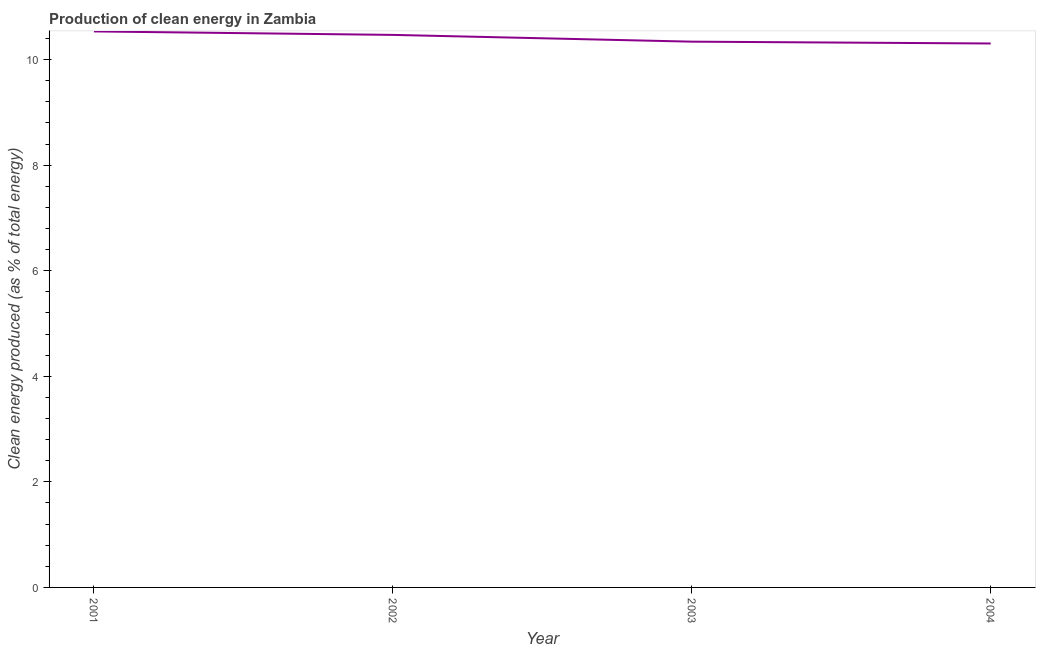What is the production of clean energy in 2001?
Your response must be concise. 10.53. Across all years, what is the maximum production of clean energy?
Offer a terse response. 10.53. Across all years, what is the minimum production of clean energy?
Your response must be concise. 10.3. In which year was the production of clean energy maximum?
Offer a terse response. 2001. What is the sum of the production of clean energy?
Ensure brevity in your answer.  41.64. What is the difference between the production of clean energy in 2002 and 2003?
Offer a terse response. 0.13. What is the average production of clean energy per year?
Offer a terse response. 10.41. What is the median production of clean energy?
Keep it short and to the point. 10.4. What is the ratio of the production of clean energy in 2002 to that in 2003?
Offer a very short reply. 1.01. Is the difference between the production of clean energy in 2002 and 2003 greater than the difference between any two years?
Your answer should be very brief. No. What is the difference between the highest and the second highest production of clean energy?
Offer a very short reply. 0.07. What is the difference between the highest and the lowest production of clean energy?
Provide a succinct answer. 0.23. In how many years, is the production of clean energy greater than the average production of clean energy taken over all years?
Your response must be concise. 2. How many lines are there?
Make the answer very short. 1. What is the difference between two consecutive major ticks on the Y-axis?
Make the answer very short. 2. Does the graph contain grids?
Your answer should be compact. No. What is the title of the graph?
Provide a succinct answer. Production of clean energy in Zambia. What is the label or title of the Y-axis?
Offer a very short reply. Clean energy produced (as % of total energy). What is the Clean energy produced (as % of total energy) in 2001?
Make the answer very short. 10.53. What is the Clean energy produced (as % of total energy) of 2002?
Your answer should be very brief. 10.47. What is the Clean energy produced (as % of total energy) in 2003?
Give a very brief answer. 10.34. What is the Clean energy produced (as % of total energy) of 2004?
Your response must be concise. 10.3. What is the difference between the Clean energy produced (as % of total energy) in 2001 and 2002?
Make the answer very short. 0.07. What is the difference between the Clean energy produced (as % of total energy) in 2001 and 2003?
Offer a very short reply. 0.19. What is the difference between the Clean energy produced (as % of total energy) in 2001 and 2004?
Keep it short and to the point. 0.23. What is the difference between the Clean energy produced (as % of total energy) in 2002 and 2003?
Provide a short and direct response. 0.13. What is the difference between the Clean energy produced (as % of total energy) in 2002 and 2004?
Your answer should be compact. 0.16. What is the difference between the Clean energy produced (as % of total energy) in 2003 and 2004?
Ensure brevity in your answer.  0.03. What is the ratio of the Clean energy produced (as % of total energy) in 2001 to that in 2002?
Provide a short and direct response. 1.01. What is the ratio of the Clean energy produced (as % of total energy) in 2001 to that in 2003?
Keep it short and to the point. 1.02. What is the ratio of the Clean energy produced (as % of total energy) in 2001 to that in 2004?
Your answer should be compact. 1.02. What is the ratio of the Clean energy produced (as % of total energy) in 2002 to that in 2003?
Ensure brevity in your answer.  1.01. What is the ratio of the Clean energy produced (as % of total energy) in 2002 to that in 2004?
Offer a terse response. 1.02. 